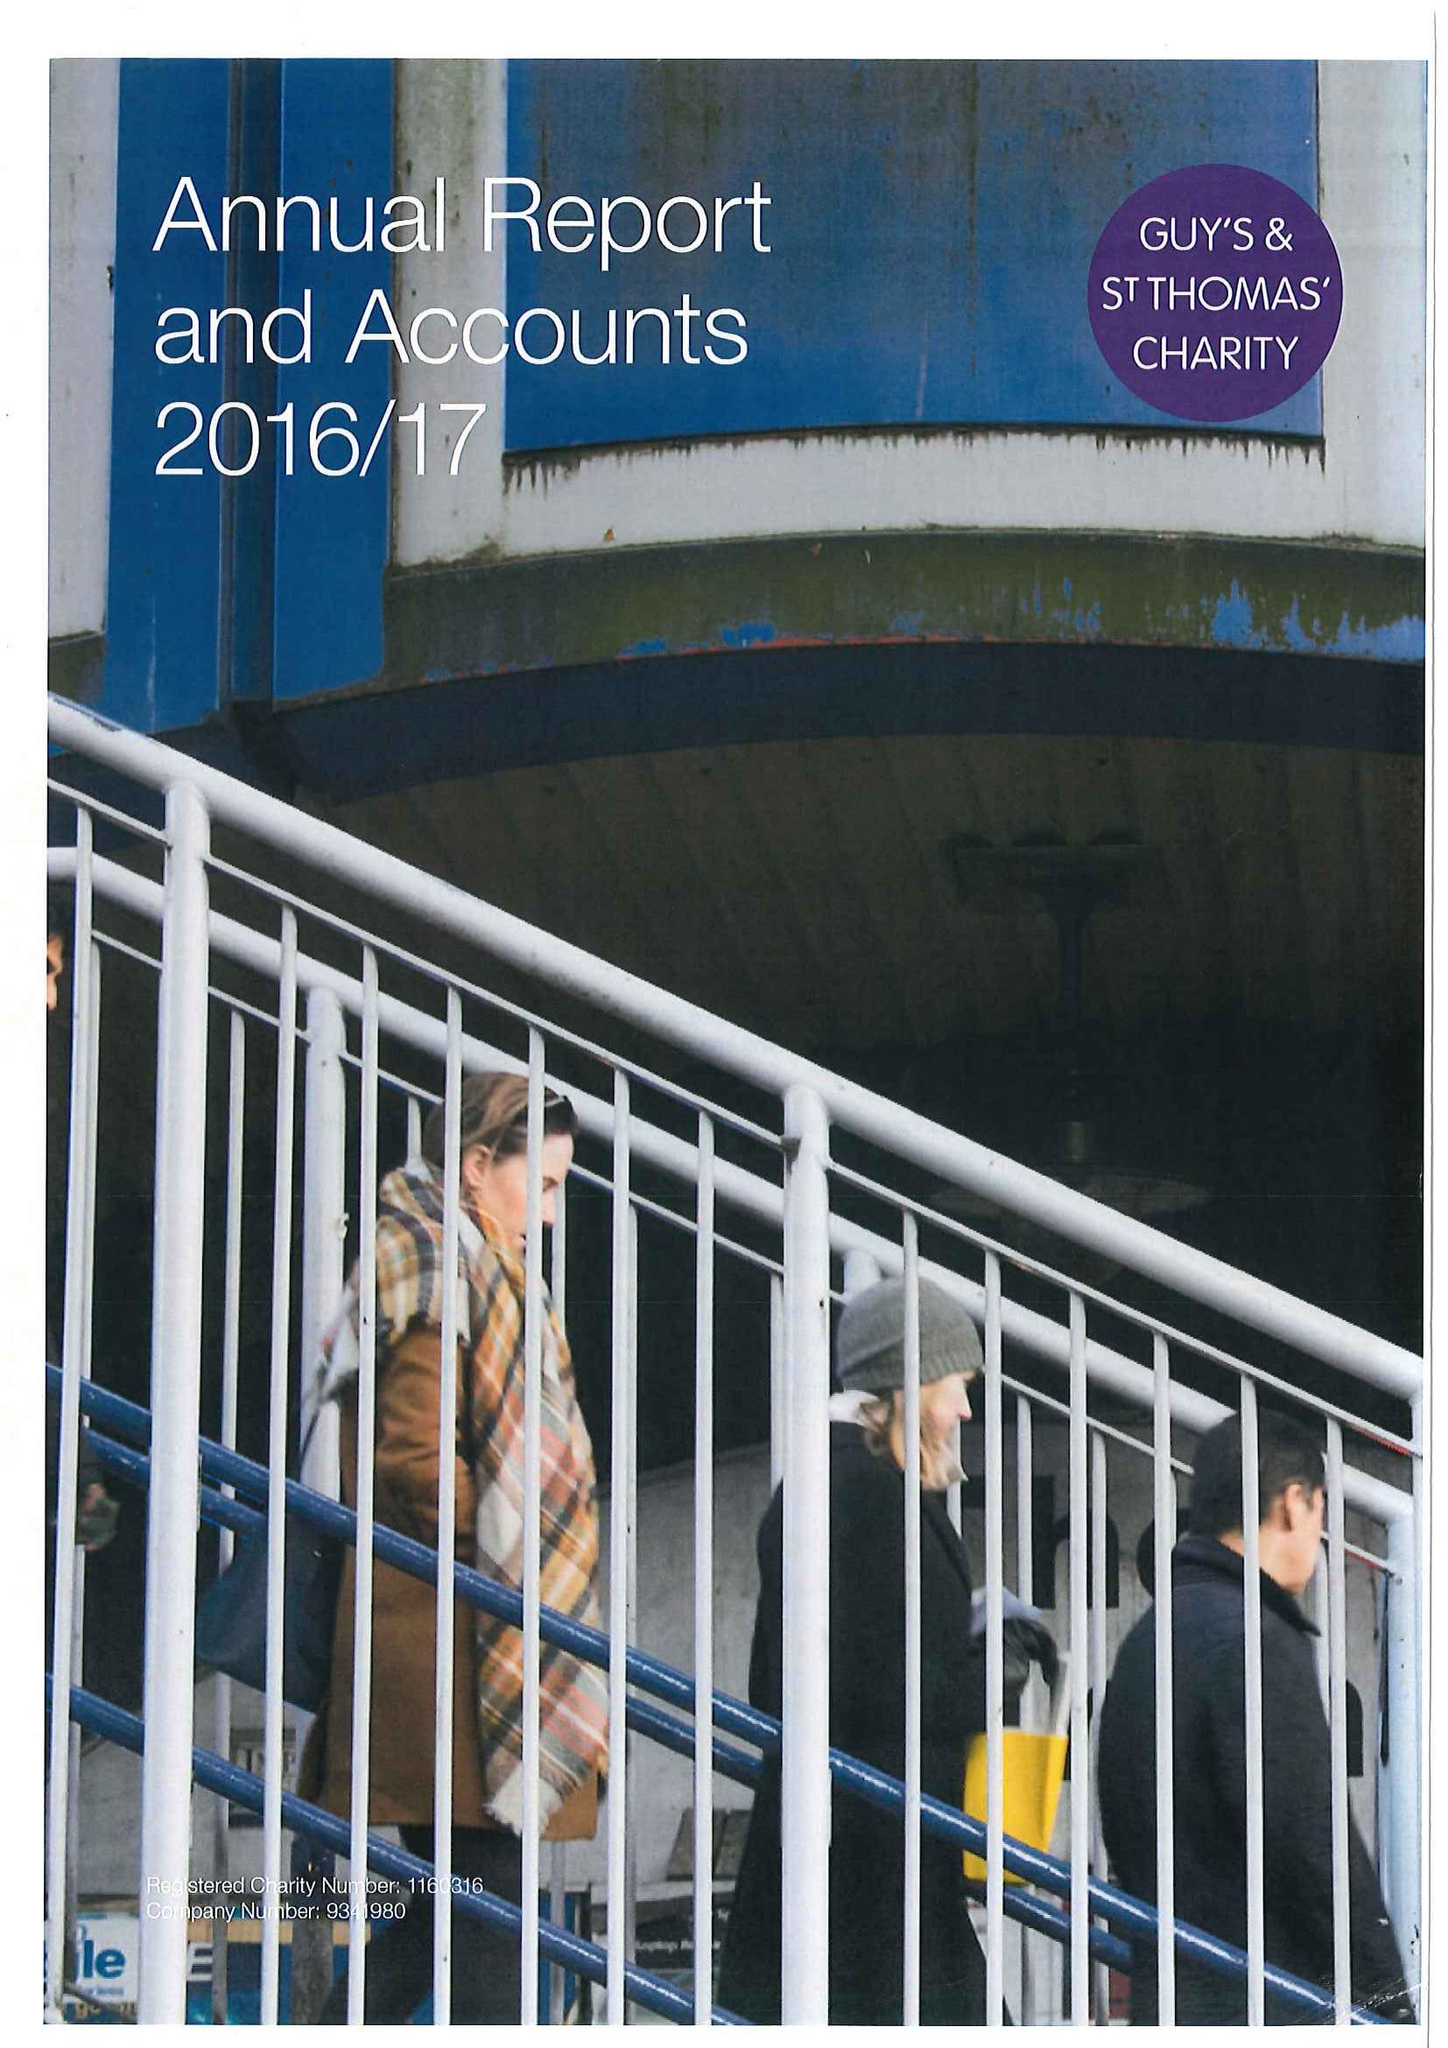What is the value for the address__post_town?
Answer the question using a single word or phrase. LONDON 